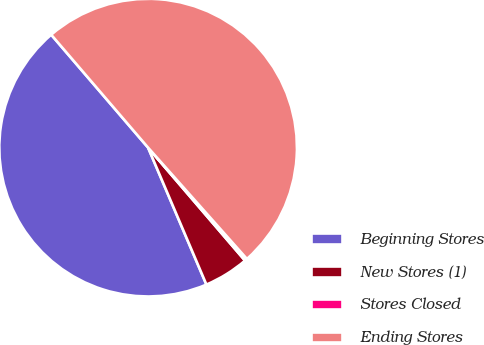<chart> <loc_0><loc_0><loc_500><loc_500><pie_chart><fcel>Beginning Stores<fcel>New Stores (1)<fcel>Stores Closed<fcel>Ending Stores<nl><fcel>45.12%<fcel>4.88%<fcel>0.27%<fcel>49.73%<nl></chart> 